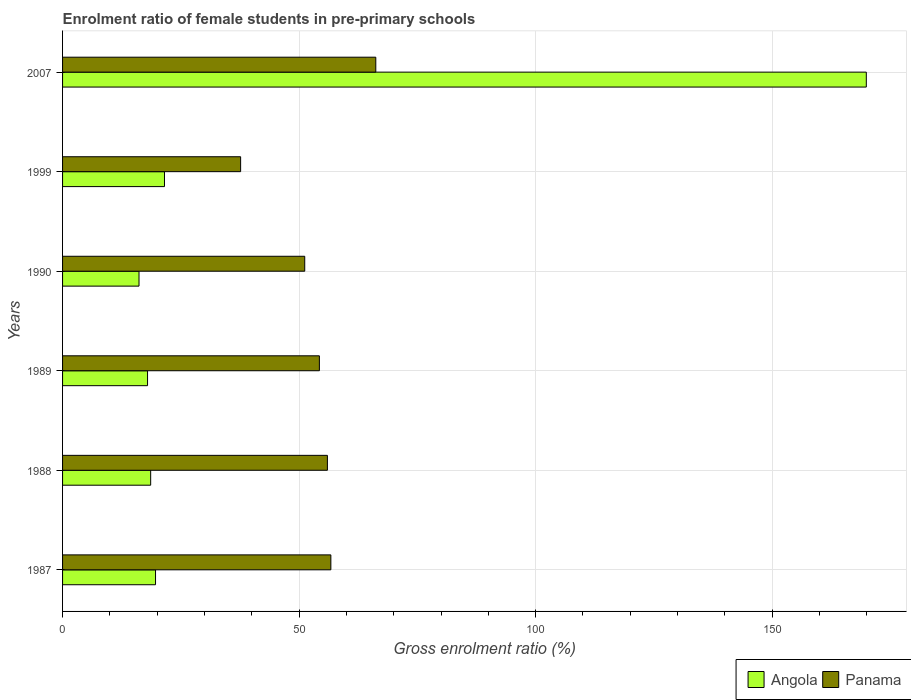How many different coloured bars are there?
Provide a succinct answer. 2. Are the number of bars per tick equal to the number of legend labels?
Provide a succinct answer. Yes. Are the number of bars on each tick of the Y-axis equal?
Provide a succinct answer. Yes. How many bars are there on the 2nd tick from the bottom?
Keep it short and to the point. 2. What is the enrolment ratio of female students in pre-primary schools in Angola in 1988?
Your answer should be very brief. 18.63. Across all years, what is the maximum enrolment ratio of female students in pre-primary schools in Panama?
Keep it short and to the point. 66.21. Across all years, what is the minimum enrolment ratio of female students in pre-primary schools in Panama?
Make the answer very short. 37.64. In which year was the enrolment ratio of female students in pre-primary schools in Angola minimum?
Your answer should be very brief. 1990. What is the total enrolment ratio of female students in pre-primary schools in Panama in the graph?
Ensure brevity in your answer.  322.03. What is the difference between the enrolment ratio of female students in pre-primary schools in Angola in 1987 and that in 1999?
Provide a succinct answer. -1.89. What is the difference between the enrolment ratio of female students in pre-primary schools in Angola in 1990 and the enrolment ratio of female students in pre-primary schools in Panama in 1989?
Your response must be concise. -38.13. What is the average enrolment ratio of female students in pre-primary schools in Panama per year?
Your response must be concise. 53.67. In the year 1999, what is the difference between the enrolment ratio of female students in pre-primary schools in Angola and enrolment ratio of female students in pre-primary schools in Panama?
Provide a short and direct response. -16.1. What is the ratio of the enrolment ratio of female students in pre-primary schools in Angola in 1987 to that in 1988?
Ensure brevity in your answer.  1.05. Is the enrolment ratio of female students in pre-primary schools in Panama in 1990 less than that in 2007?
Offer a terse response. Yes. What is the difference between the highest and the second highest enrolment ratio of female students in pre-primary schools in Angola?
Provide a succinct answer. 148.36. What is the difference between the highest and the lowest enrolment ratio of female students in pre-primary schools in Angola?
Offer a very short reply. 153.74. In how many years, is the enrolment ratio of female students in pre-primary schools in Angola greater than the average enrolment ratio of female students in pre-primary schools in Angola taken over all years?
Make the answer very short. 1. What does the 2nd bar from the top in 2007 represents?
Make the answer very short. Angola. What does the 2nd bar from the bottom in 1987 represents?
Ensure brevity in your answer.  Panama. Are all the bars in the graph horizontal?
Ensure brevity in your answer.  Yes. Are the values on the major ticks of X-axis written in scientific E-notation?
Provide a short and direct response. No. Does the graph contain any zero values?
Ensure brevity in your answer.  No. How many legend labels are there?
Your response must be concise. 2. How are the legend labels stacked?
Keep it short and to the point. Horizontal. What is the title of the graph?
Your answer should be very brief. Enrolment ratio of female students in pre-primary schools. What is the label or title of the X-axis?
Give a very brief answer. Gross enrolment ratio (%). What is the Gross enrolment ratio (%) in Angola in 1987?
Offer a terse response. 19.65. What is the Gross enrolment ratio (%) in Panama in 1987?
Your answer should be very brief. 56.72. What is the Gross enrolment ratio (%) of Angola in 1988?
Give a very brief answer. 18.63. What is the Gross enrolment ratio (%) in Panama in 1988?
Ensure brevity in your answer.  55.98. What is the Gross enrolment ratio (%) of Angola in 1989?
Offer a terse response. 17.96. What is the Gross enrolment ratio (%) in Panama in 1989?
Your answer should be compact. 54.29. What is the Gross enrolment ratio (%) in Angola in 1990?
Offer a very short reply. 16.16. What is the Gross enrolment ratio (%) in Panama in 1990?
Make the answer very short. 51.19. What is the Gross enrolment ratio (%) of Angola in 1999?
Your response must be concise. 21.54. What is the Gross enrolment ratio (%) of Panama in 1999?
Give a very brief answer. 37.64. What is the Gross enrolment ratio (%) of Angola in 2007?
Your response must be concise. 169.9. What is the Gross enrolment ratio (%) of Panama in 2007?
Provide a short and direct response. 66.21. Across all years, what is the maximum Gross enrolment ratio (%) in Angola?
Your answer should be compact. 169.9. Across all years, what is the maximum Gross enrolment ratio (%) of Panama?
Make the answer very short. 66.21. Across all years, what is the minimum Gross enrolment ratio (%) in Angola?
Give a very brief answer. 16.16. Across all years, what is the minimum Gross enrolment ratio (%) in Panama?
Ensure brevity in your answer.  37.64. What is the total Gross enrolment ratio (%) in Angola in the graph?
Your response must be concise. 263.84. What is the total Gross enrolment ratio (%) in Panama in the graph?
Ensure brevity in your answer.  322.03. What is the difference between the Gross enrolment ratio (%) in Angola in 1987 and that in 1988?
Provide a succinct answer. 1.02. What is the difference between the Gross enrolment ratio (%) in Panama in 1987 and that in 1988?
Your answer should be very brief. 0.73. What is the difference between the Gross enrolment ratio (%) of Angola in 1987 and that in 1989?
Give a very brief answer. 1.69. What is the difference between the Gross enrolment ratio (%) in Panama in 1987 and that in 1989?
Provide a succinct answer. 2.43. What is the difference between the Gross enrolment ratio (%) in Angola in 1987 and that in 1990?
Offer a very short reply. 3.49. What is the difference between the Gross enrolment ratio (%) in Panama in 1987 and that in 1990?
Your response must be concise. 5.53. What is the difference between the Gross enrolment ratio (%) in Angola in 1987 and that in 1999?
Keep it short and to the point. -1.89. What is the difference between the Gross enrolment ratio (%) of Panama in 1987 and that in 1999?
Provide a short and direct response. 19.08. What is the difference between the Gross enrolment ratio (%) of Angola in 1987 and that in 2007?
Offer a very short reply. -150.25. What is the difference between the Gross enrolment ratio (%) of Panama in 1987 and that in 2007?
Keep it short and to the point. -9.5. What is the difference between the Gross enrolment ratio (%) of Angola in 1988 and that in 1989?
Offer a terse response. 0.66. What is the difference between the Gross enrolment ratio (%) in Panama in 1988 and that in 1989?
Make the answer very short. 1.7. What is the difference between the Gross enrolment ratio (%) of Angola in 1988 and that in 1990?
Your response must be concise. 2.47. What is the difference between the Gross enrolment ratio (%) of Panama in 1988 and that in 1990?
Your answer should be compact. 4.79. What is the difference between the Gross enrolment ratio (%) of Angola in 1988 and that in 1999?
Offer a very short reply. -2.92. What is the difference between the Gross enrolment ratio (%) of Panama in 1988 and that in 1999?
Offer a terse response. 18.34. What is the difference between the Gross enrolment ratio (%) in Angola in 1988 and that in 2007?
Make the answer very short. -151.27. What is the difference between the Gross enrolment ratio (%) in Panama in 1988 and that in 2007?
Ensure brevity in your answer.  -10.23. What is the difference between the Gross enrolment ratio (%) in Angola in 1989 and that in 1990?
Ensure brevity in your answer.  1.81. What is the difference between the Gross enrolment ratio (%) of Panama in 1989 and that in 1990?
Offer a very short reply. 3.1. What is the difference between the Gross enrolment ratio (%) of Angola in 1989 and that in 1999?
Provide a succinct answer. -3.58. What is the difference between the Gross enrolment ratio (%) in Panama in 1989 and that in 1999?
Make the answer very short. 16.65. What is the difference between the Gross enrolment ratio (%) in Angola in 1989 and that in 2007?
Offer a very short reply. -151.93. What is the difference between the Gross enrolment ratio (%) in Panama in 1989 and that in 2007?
Ensure brevity in your answer.  -11.92. What is the difference between the Gross enrolment ratio (%) in Angola in 1990 and that in 1999?
Your answer should be compact. -5.38. What is the difference between the Gross enrolment ratio (%) of Panama in 1990 and that in 1999?
Offer a terse response. 13.55. What is the difference between the Gross enrolment ratio (%) in Angola in 1990 and that in 2007?
Your answer should be very brief. -153.74. What is the difference between the Gross enrolment ratio (%) in Panama in 1990 and that in 2007?
Make the answer very short. -15.02. What is the difference between the Gross enrolment ratio (%) in Angola in 1999 and that in 2007?
Offer a terse response. -148.36. What is the difference between the Gross enrolment ratio (%) in Panama in 1999 and that in 2007?
Your answer should be very brief. -28.57. What is the difference between the Gross enrolment ratio (%) of Angola in 1987 and the Gross enrolment ratio (%) of Panama in 1988?
Provide a succinct answer. -36.33. What is the difference between the Gross enrolment ratio (%) in Angola in 1987 and the Gross enrolment ratio (%) in Panama in 1989?
Offer a very short reply. -34.64. What is the difference between the Gross enrolment ratio (%) in Angola in 1987 and the Gross enrolment ratio (%) in Panama in 1990?
Provide a short and direct response. -31.54. What is the difference between the Gross enrolment ratio (%) of Angola in 1987 and the Gross enrolment ratio (%) of Panama in 1999?
Give a very brief answer. -17.99. What is the difference between the Gross enrolment ratio (%) in Angola in 1987 and the Gross enrolment ratio (%) in Panama in 2007?
Keep it short and to the point. -46.56. What is the difference between the Gross enrolment ratio (%) in Angola in 1988 and the Gross enrolment ratio (%) in Panama in 1989?
Your answer should be compact. -35.66. What is the difference between the Gross enrolment ratio (%) of Angola in 1988 and the Gross enrolment ratio (%) of Panama in 1990?
Offer a terse response. -32.56. What is the difference between the Gross enrolment ratio (%) of Angola in 1988 and the Gross enrolment ratio (%) of Panama in 1999?
Ensure brevity in your answer.  -19.01. What is the difference between the Gross enrolment ratio (%) of Angola in 1988 and the Gross enrolment ratio (%) of Panama in 2007?
Offer a terse response. -47.59. What is the difference between the Gross enrolment ratio (%) in Angola in 1989 and the Gross enrolment ratio (%) in Panama in 1990?
Your response must be concise. -33.23. What is the difference between the Gross enrolment ratio (%) of Angola in 1989 and the Gross enrolment ratio (%) of Panama in 1999?
Provide a succinct answer. -19.68. What is the difference between the Gross enrolment ratio (%) in Angola in 1989 and the Gross enrolment ratio (%) in Panama in 2007?
Provide a short and direct response. -48.25. What is the difference between the Gross enrolment ratio (%) in Angola in 1990 and the Gross enrolment ratio (%) in Panama in 1999?
Keep it short and to the point. -21.48. What is the difference between the Gross enrolment ratio (%) in Angola in 1990 and the Gross enrolment ratio (%) in Panama in 2007?
Keep it short and to the point. -50.05. What is the difference between the Gross enrolment ratio (%) of Angola in 1999 and the Gross enrolment ratio (%) of Panama in 2007?
Provide a succinct answer. -44.67. What is the average Gross enrolment ratio (%) of Angola per year?
Keep it short and to the point. 43.97. What is the average Gross enrolment ratio (%) of Panama per year?
Your answer should be very brief. 53.67. In the year 1987, what is the difference between the Gross enrolment ratio (%) in Angola and Gross enrolment ratio (%) in Panama?
Offer a terse response. -37.07. In the year 1988, what is the difference between the Gross enrolment ratio (%) in Angola and Gross enrolment ratio (%) in Panama?
Your answer should be compact. -37.36. In the year 1989, what is the difference between the Gross enrolment ratio (%) of Angola and Gross enrolment ratio (%) of Panama?
Provide a succinct answer. -36.32. In the year 1990, what is the difference between the Gross enrolment ratio (%) of Angola and Gross enrolment ratio (%) of Panama?
Give a very brief answer. -35.03. In the year 1999, what is the difference between the Gross enrolment ratio (%) of Angola and Gross enrolment ratio (%) of Panama?
Make the answer very short. -16.1. In the year 2007, what is the difference between the Gross enrolment ratio (%) of Angola and Gross enrolment ratio (%) of Panama?
Your answer should be very brief. 103.69. What is the ratio of the Gross enrolment ratio (%) of Angola in 1987 to that in 1988?
Make the answer very short. 1.05. What is the ratio of the Gross enrolment ratio (%) of Panama in 1987 to that in 1988?
Provide a succinct answer. 1.01. What is the ratio of the Gross enrolment ratio (%) of Angola in 1987 to that in 1989?
Provide a succinct answer. 1.09. What is the ratio of the Gross enrolment ratio (%) in Panama in 1987 to that in 1989?
Make the answer very short. 1.04. What is the ratio of the Gross enrolment ratio (%) of Angola in 1987 to that in 1990?
Give a very brief answer. 1.22. What is the ratio of the Gross enrolment ratio (%) of Panama in 1987 to that in 1990?
Provide a short and direct response. 1.11. What is the ratio of the Gross enrolment ratio (%) in Angola in 1987 to that in 1999?
Your response must be concise. 0.91. What is the ratio of the Gross enrolment ratio (%) in Panama in 1987 to that in 1999?
Give a very brief answer. 1.51. What is the ratio of the Gross enrolment ratio (%) in Angola in 1987 to that in 2007?
Offer a terse response. 0.12. What is the ratio of the Gross enrolment ratio (%) in Panama in 1987 to that in 2007?
Give a very brief answer. 0.86. What is the ratio of the Gross enrolment ratio (%) of Angola in 1988 to that in 1989?
Provide a succinct answer. 1.04. What is the ratio of the Gross enrolment ratio (%) of Panama in 1988 to that in 1989?
Ensure brevity in your answer.  1.03. What is the ratio of the Gross enrolment ratio (%) in Angola in 1988 to that in 1990?
Keep it short and to the point. 1.15. What is the ratio of the Gross enrolment ratio (%) in Panama in 1988 to that in 1990?
Offer a very short reply. 1.09. What is the ratio of the Gross enrolment ratio (%) of Angola in 1988 to that in 1999?
Keep it short and to the point. 0.86. What is the ratio of the Gross enrolment ratio (%) in Panama in 1988 to that in 1999?
Offer a very short reply. 1.49. What is the ratio of the Gross enrolment ratio (%) in Angola in 1988 to that in 2007?
Keep it short and to the point. 0.11. What is the ratio of the Gross enrolment ratio (%) of Panama in 1988 to that in 2007?
Make the answer very short. 0.85. What is the ratio of the Gross enrolment ratio (%) in Angola in 1989 to that in 1990?
Provide a succinct answer. 1.11. What is the ratio of the Gross enrolment ratio (%) of Panama in 1989 to that in 1990?
Your answer should be compact. 1.06. What is the ratio of the Gross enrolment ratio (%) of Angola in 1989 to that in 1999?
Offer a terse response. 0.83. What is the ratio of the Gross enrolment ratio (%) of Panama in 1989 to that in 1999?
Keep it short and to the point. 1.44. What is the ratio of the Gross enrolment ratio (%) of Angola in 1989 to that in 2007?
Your answer should be very brief. 0.11. What is the ratio of the Gross enrolment ratio (%) in Panama in 1989 to that in 2007?
Give a very brief answer. 0.82. What is the ratio of the Gross enrolment ratio (%) of Angola in 1990 to that in 1999?
Provide a succinct answer. 0.75. What is the ratio of the Gross enrolment ratio (%) of Panama in 1990 to that in 1999?
Provide a succinct answer. 1.36. What is the ratio of the Gross enrolment ratio (%) in Angola in 1990 to that in 2007?
Provide a succinct answer. 0.1. What is the ratio of the Gross enrolment ratio (%) of Panama in 1990 to that in 2007?
Provide a succinct answer. 0.77. What is the ratio of the Gross enrolment ratio (%) in Angola in 1999 to that in 2007?
Give a very brief answer. 0.13. What is the ratio of the Gross enrolment ratio (%) in Panama in 1999 to that in 2007?
Keep it short and to the point. 0.57. What is the difference between the highest and the second highest Gross enrolment ratio (%) of Angola?
Provide a short and direct response. 148.36. What is the difference between the highest and the second highest Gross enrolment ratio (%) of Panama?
Make the answer very short. 9.5. What is the difference between the highest and the lowest Gross enrolment ratio (%) of Angola?
Keep it short and to the point. 153.74. What is the difference between the highest and the lowest Gross enrolment ratio (%) of Panama?
Offer a very short reply. 28.57. 